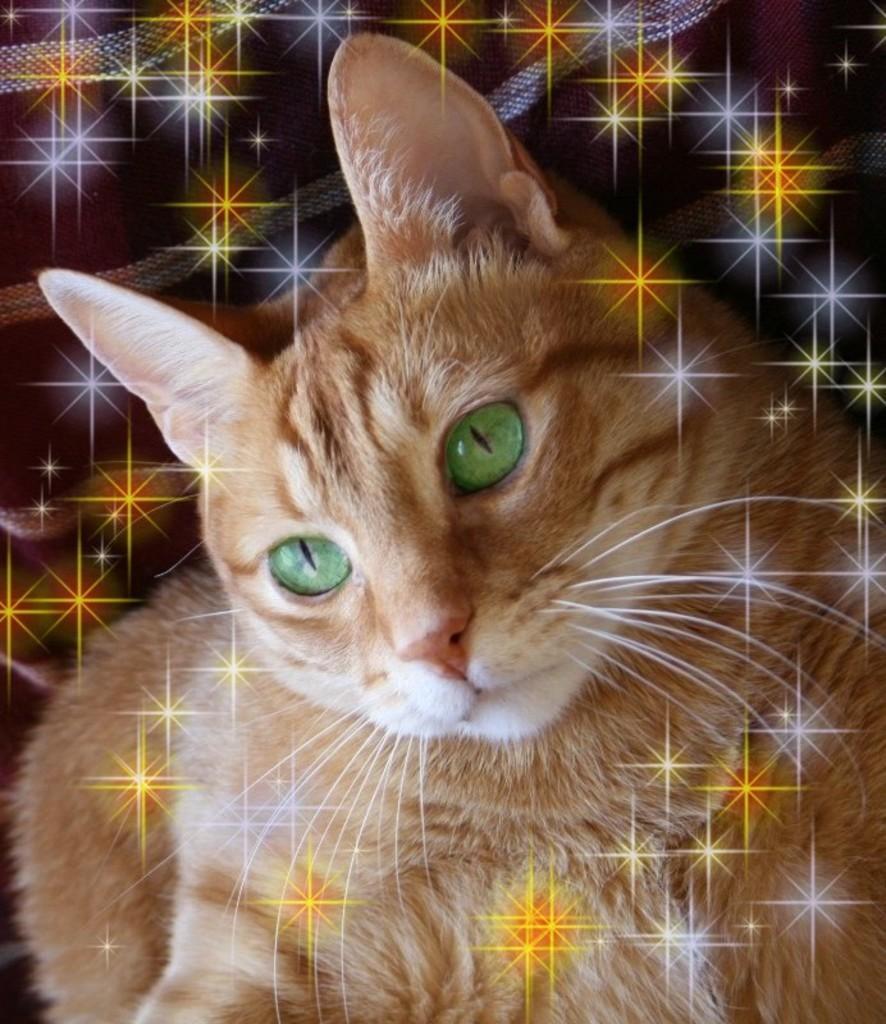Please provide a concise description of this image. In this image I can see a cream colour cat. 